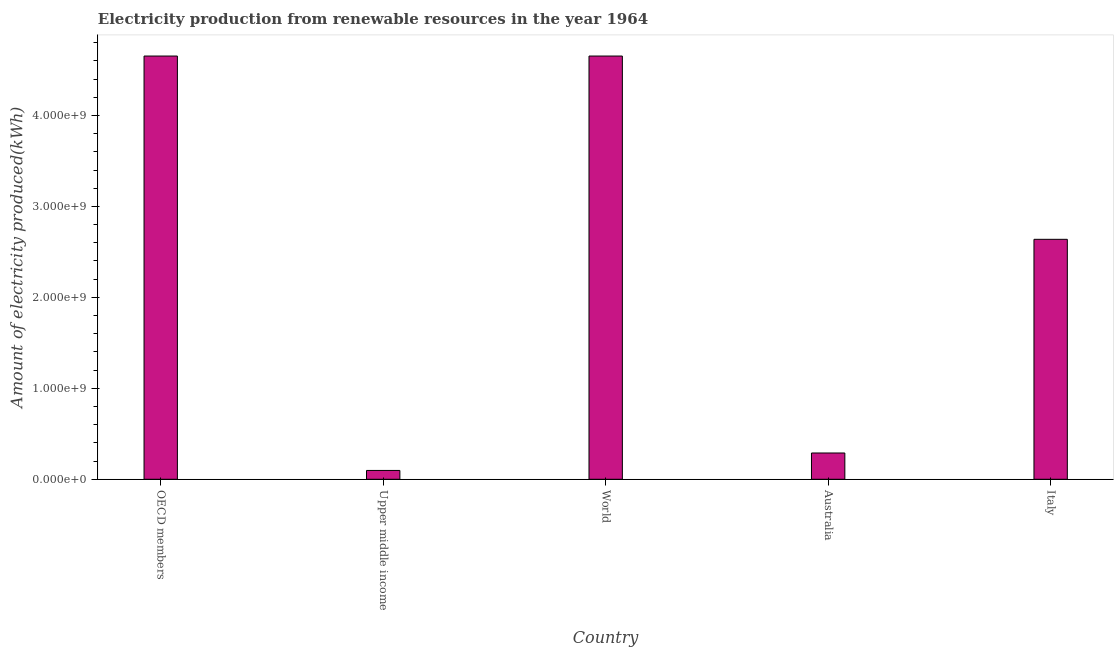Does the graph contain grids?
Keep it short and to the point. No. What is the title of the graph?
Your response must be concise. Electricity production from renewable resources in the year 1964. What is the label or title of the X-axis?
Give a very brief answer. Country. What is the label or title of the Y-axis?
Your answer should be very brief. Amount of electricity produced(kWh). What is the amount of electricity produced in World?
Ensure brevity in your answer.  4.65e+09. Across all countries, what is the maximum amount of electricity produced?
Provide a succinct answer. 4.65e+09. Across all countries, what is the minimum amount of electricity produced?
Provide a succinct answer. 9.70e+07. In which country was the amount of electricity produced minimum?
Give a very brief answer. Upper middle income. What is the sum of the amount of electricity produced?
Your answer should be compact. 1.23e+1. What is the difference between the amount of electricity produced in Upper middle income and World?
Offer a terse response. -4.56e+09. What is the average amount of electricity produced per country?
Your answer should be very brief. 2.47e+09. What is the median amount of electricity produced?
Keep it short and to the point. 2.64e+09. What is the ratio of the amount of electricity produced in Upper middle income to that in World?
Ensure brevity in your answer.  0.02. Is the difference between the amount of electricity produced in Italy and World greater than the difference between any two countries?
Provide a short and direct response. No. What is the difference between the highest and the second highest amount of electricity produced?
Keep it short and to the point. 0. What is the difference between the highest and the lowest amount of electricity produced?
Offer a very short reply. 4.56e+09. In how many countries, is the amount of electricity produced greater than the average amount of electricity produced taken over all countries?
Your response must be concise. 3. Are all the bars in the graph horizontal?
Your answer should be very brief. No. How many countries are there in the graph?
Provide a succinct answer. 5. What is the Amount of electricity produced(kWh) of OECD members?
Your answer should be very brief. 4.65e+09. What is the Amount of electricity produced(kWh) of Upper middle income?
Provide a short and direct response. 9.70e+07. What is the Amount of electricity produced(kWh) in World?
Provide a succinct answer. 4.65e+09. What is the Amount of electricity produced(kWh) of Australia?
Provide a short and direct response. 2.89e+08. What is the Amount of electricity produced(kWh) in Italy?
Provide a short and direct response. 2.64e+09. What is the difference between the Amount of electricity produced(kWh) in OECD members and Upper middle income?
Your answer should be very brief. 4.56e+09. What is the difference between the Amount of electricity produced(kWh) in OECD members and Australia?
Make the answer very short. 4.36e+09. What is the difference between the Amount of electricity produced(kWh) in OECD members and Italy?
Provide a succinct answer. 2.02e+09. What is the difference between the Amount of electricity produced(kWh) in Upper middle income and World?
Offer a terse response. -4.56e+09. What is the difference between the Amount of electricity produced(kWh) in Upper middle income and Australia?
Your response must be concise. -1.92e+08. What is the difference between the Amount of electricity produced(kWh) in Upper middle income and Italy?
Provide a succinct answer. -2.54e+09. What is the difference between the Amount of electricity produced(kWh) in World and Australia?
Keep it short and to the point. 4.36e+09. What is the difference between the Amount of electricity produced(kWh) in World and Italy?
Give a very brief answer. 2.02e+09. What is the difference between the Amount of electricity produced(kWh) in Australia and Italy?
Your response must be concise. -2.35e+09. What is the ratio of the Amount of electricity produced(kWh) in OECD members to that in Upper middle income?
Give a very brief answer. 47.97. What is the ratio of the Amount of electricity produced(kWh) in OECD members to that in Italy?
Offer a terse response. 1.76. What is the ratio of the Amount of electricity produced(kWh) in Upper middle income to that in World?
Your answer should be compact. 0.02. What is the ratio of the Amount of electricity produced(kWh) in Upper middle income to that in Australia?
Your answer should be very brief. 0.34. What is the ratio of the Amount of electricity produced(kWh) in Upper middle income to that in Italy?
Keep it short and to the point. 0.04. What is the ratio of the Amount of electricity produced(kWh) in World to that in Italy?
Provide a succinct answer. 1.76. What is the ratio of the Amount of electricity produced(kWh) in Australia to that in Italy?
Your answer should be compact. 0.11. 